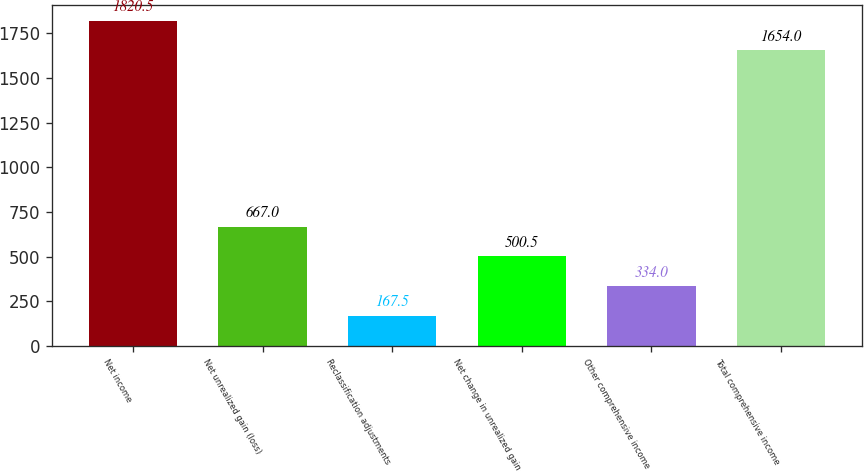Convert chart. <chart><loc_0><loc_0><loc_500><loc_500><bar_chart><fcel>Net income<fcel>Net unrealized gain (loss)<fcel>Reclassification adjustments<fcel>Net change in unrealized gain<fcel>Other comprehensive income<fcel>Total comprehensive income<nl><fcel>1820.5<fcel>667<fcel>167.5<fcel>500.5<fcel>334<fcel>1654<nl></chart> 